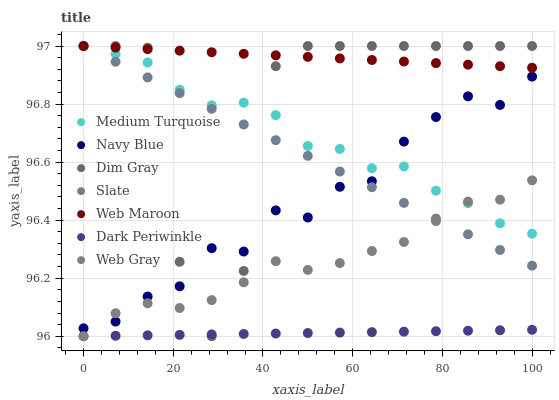Does Dark Periwinkle have the minimum area under the curve?
Answer yes or no. Yes. Does Web Maroon have the maximum area under the curve?
Answer yes or no. Yes. Does Navy Blue have the minimum area under the curve?
Answer yes or no. No. Does Navy Blue have the maximum area under the curve?
Answer yes or no. No. Is Slate the smoothest?
Answer yes or no. Yes. Is Dim Gray the roughest?
Answer yes or no. Yes. Is Navy Blue the smoothest?
Answer yes or no. No. Is Navy Blue the roughest?
Answer yes or no. No. Does Web Gray have the lowest value?
Answer yes or no. Yes. Does Navy Blue have the lowest value?
Answer yes or no. No. Does Medium Turquoise have the highest value?
Answer yes or no. Yes. Does Navy Blue have the highest value?
Answer yes or no. No. Is Dark Periwinkle less than Navy Blue?
Answer yes or no. Yes. Is Web Maroon greater than Dark Periwinkle?
Answer yes or no. Yes. Does Medium Turquoise intersect Web Gray?
Answer yes or no. Yes. Is Medium Turquoise less than Web Gray?
Answer yes or no. No. Is Medium Turquoise greater than Web Gray?
Answer yes or no. No. Does Dark Periwinkle intersect Navy Blue?
Answer yes or no. No. 